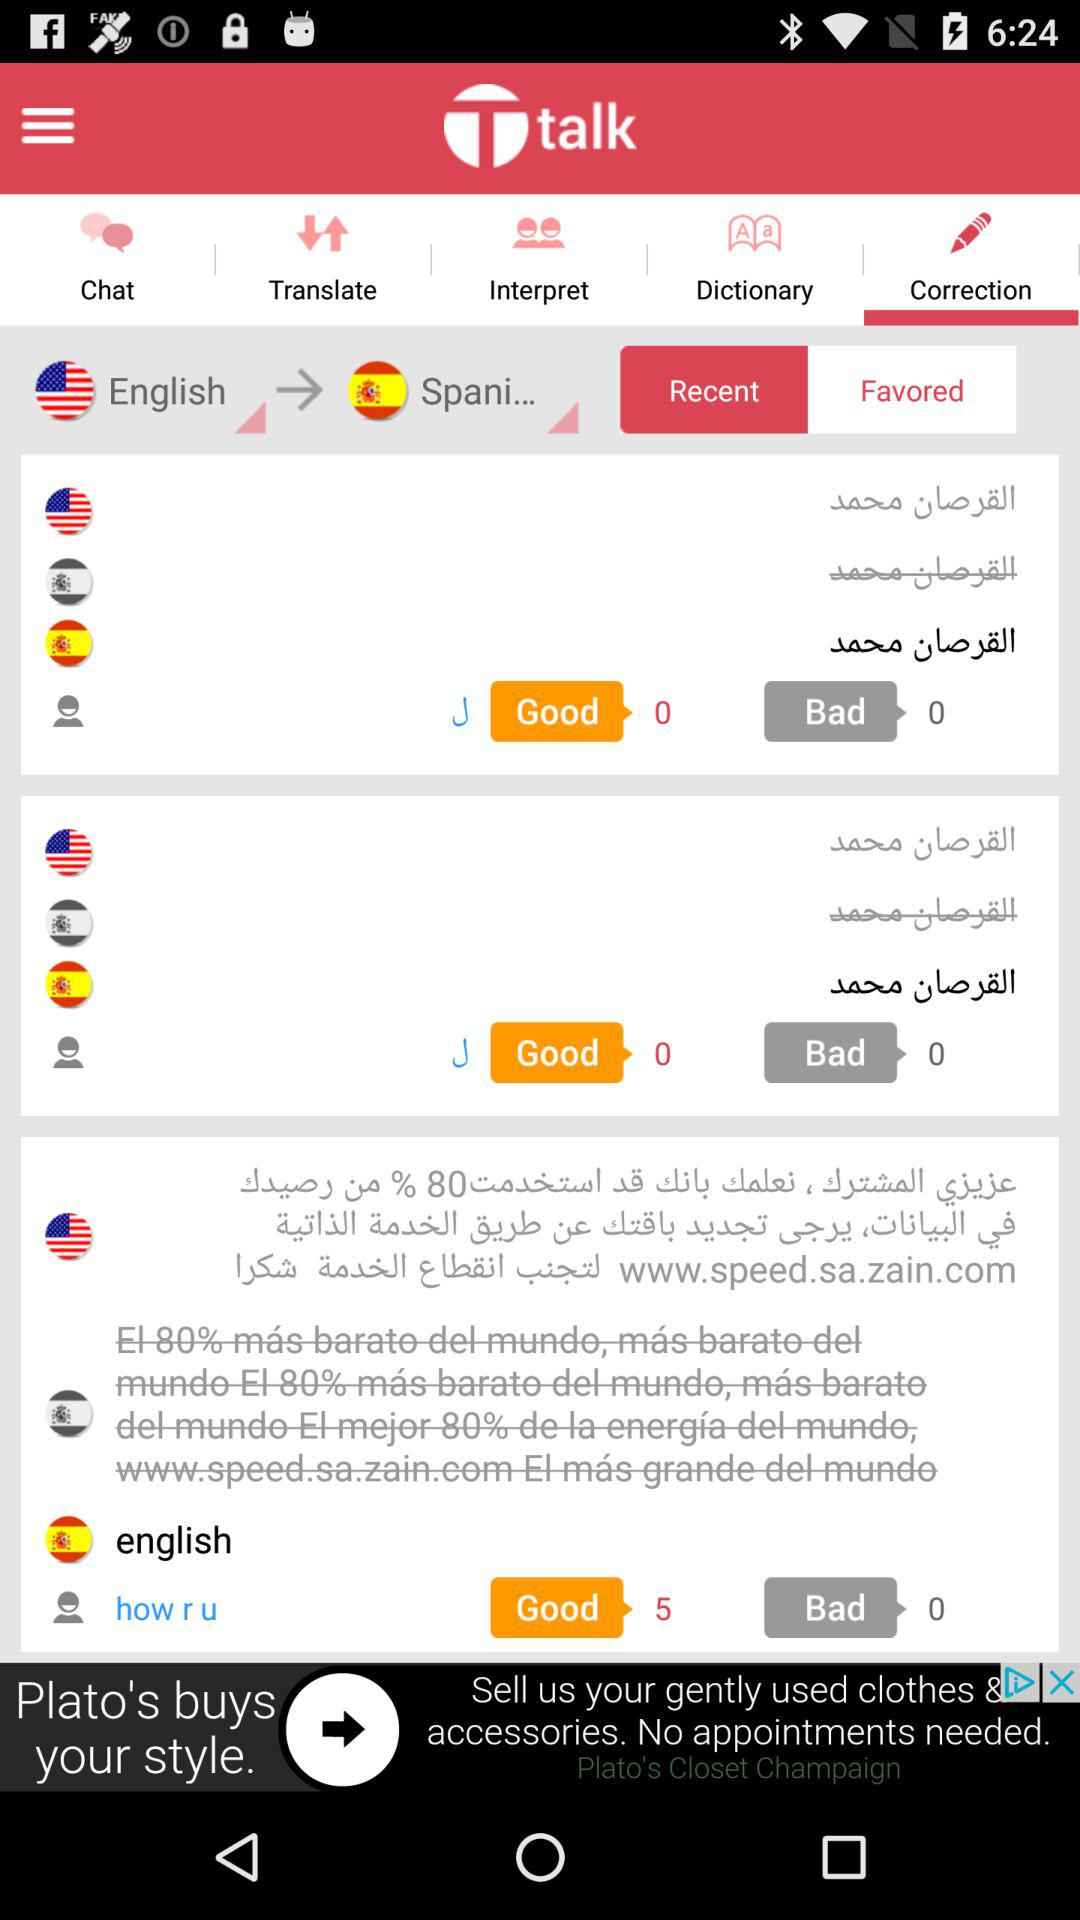Which tab is selected? The selected tab is "Correction". 